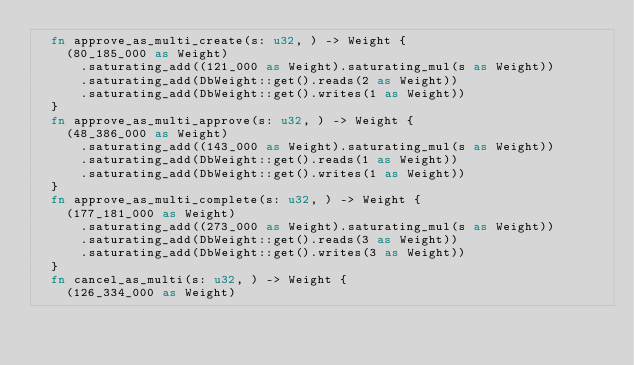Convert code to text. <code><loc_0><loc_0><loc_500><loc_500><_Rust_>	fn approve_as_multi_create(s: u32, ) -> Weight {
		(80_185_000 as Weight)
			.saturating_add((121_000 as Weight).saturating_mul(s as Weight))
			.saturating_add(DbWeight::get().reads(2 as Weight))
			.saturating_add(DbWeight::get().writes(1 as Weight))
	}
	fn approve_as_multi_approve(s: u32, ) -> Weight {
		(48_386_000 as Weight)
			.saturating_add((143_000 as Weight).saturating_mul(s as Weight))
			.saturating_add(DbWeight::get().reads(1 as Weight))
			.saturating_add(DbWeight::get().writes(1 as Weight))
	}
	fn approve_as_multi_complete(s: u32, ) -> Weight {
		(177_181_000 as Weight)
			.saturating_add((273_000 as Weight).saturating_mul(s as Weight))
			.saturating_add(DbWeight::get().reads(3 as Weight))
			.saturating_add(DbWeight::get().writes(3 as Weight))
	}
	fn cancel_as_multi(s: u32, ) -> Weight {
		(126_334_000 as Weight)</code> 